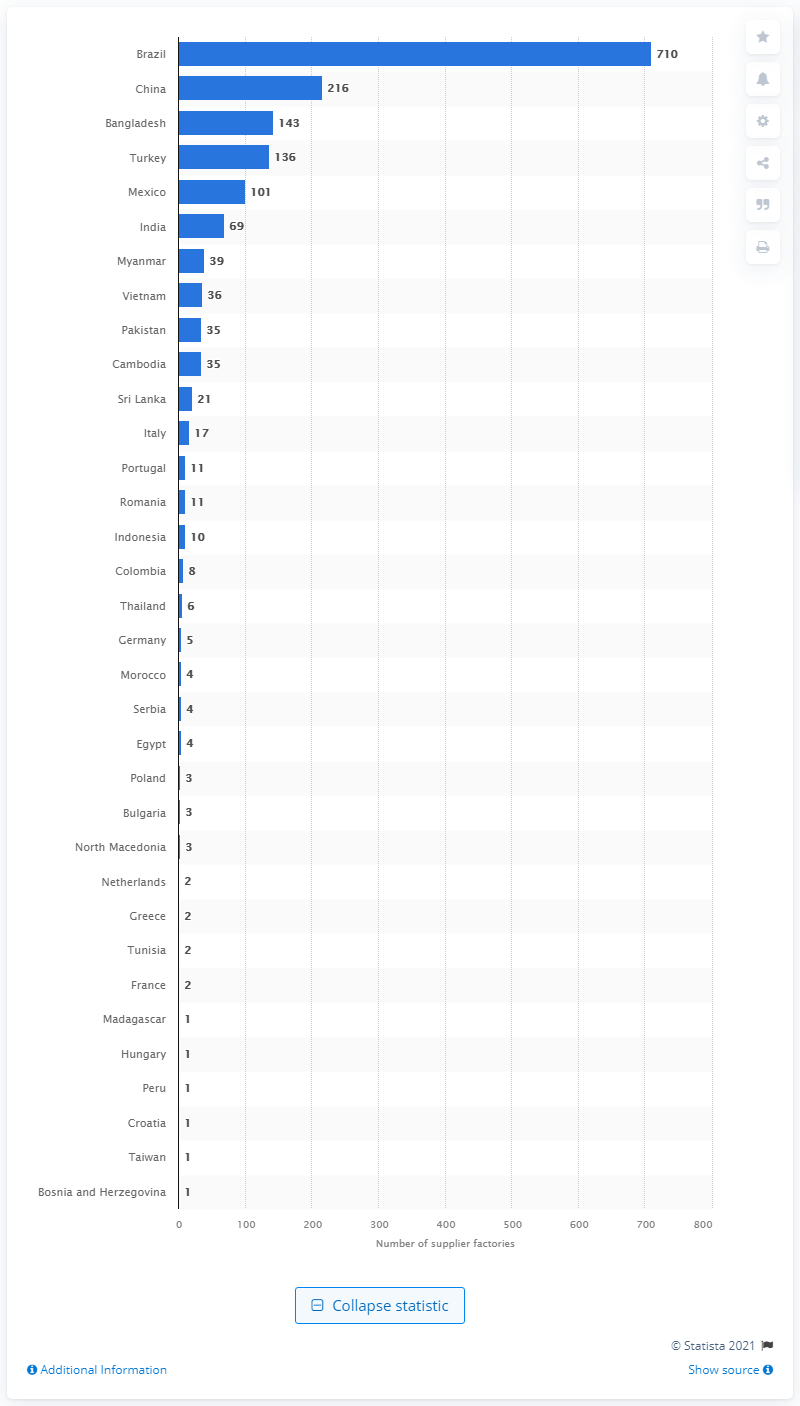Specify some key components in this picture. C&A has 143 factories in Bangladesh. C&A, a clothing retailer, sources the majority of its products from supplier factories located in Brazil, which hosts the highest number of these factories. 